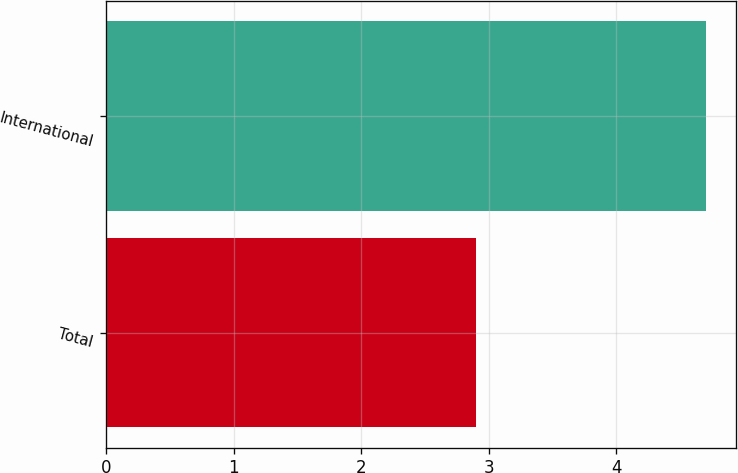Convert chart to OTSL. <chart><loc_0><loc_0><loc_500><loc_500><bar_chart><fcel>Total<fcel>International<nl><fcel>2.9<fcel>4.7<nl></chart> 